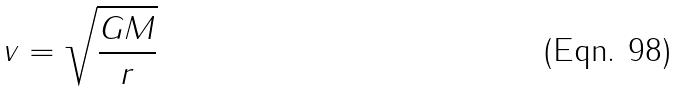<formula> <loc_0><loc_0><loc_500><loc_500>v = \sqrt { \frac { G M } { r } }</formula> 